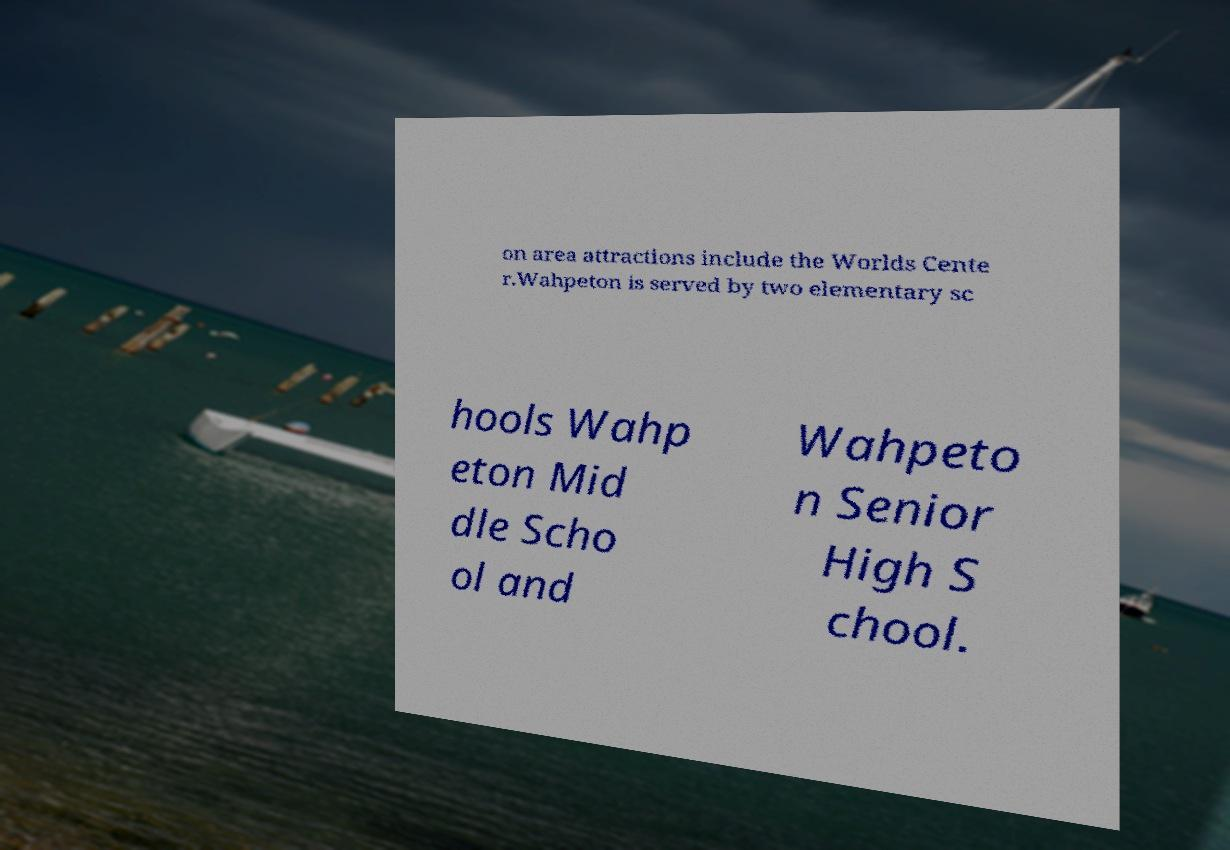I need the written content from this picture converted into text. Can you do that? on area attractions include the Worlds Cente r.Wahpeton is served by two elementary sc hools Wahp eton Mid dle Scho ol and Wahpeto n Senior High S chool. 